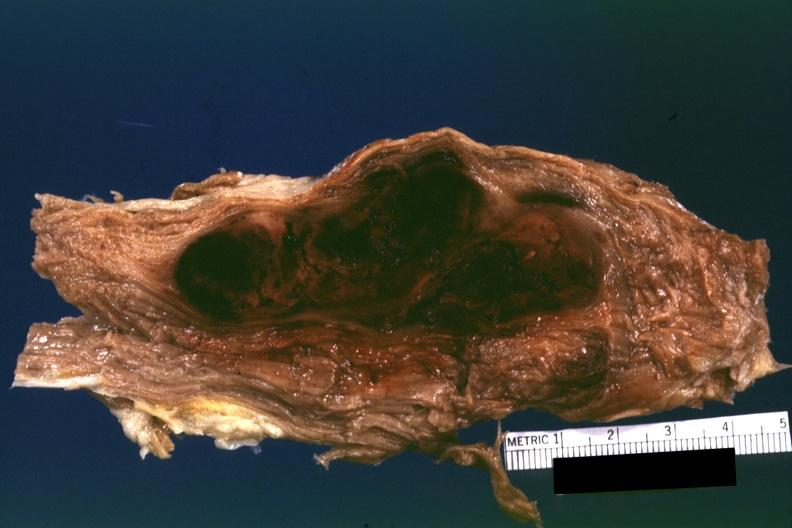what does this image show?
Answer the question using a single word or phrase. Sectioned muscle partially fixed but color ok i do not have protocol with diagnosis 